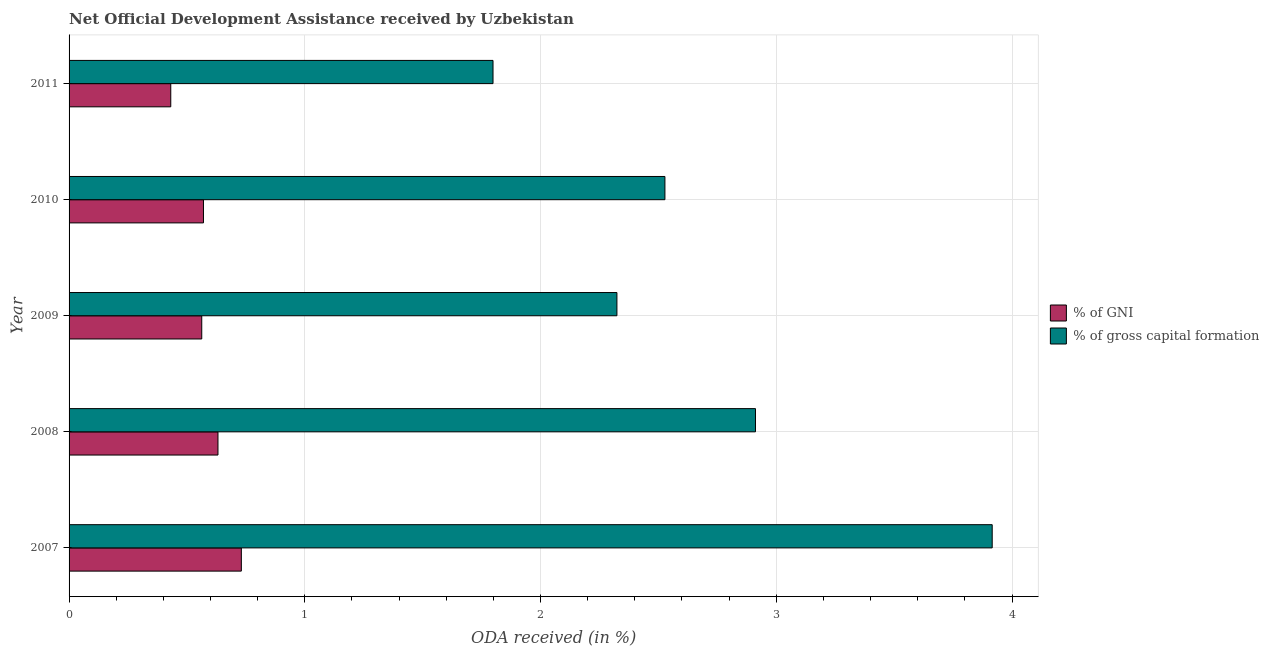Are the number of bars per tick equal to the number of legend labels?
Give a very brief answer. Yes. How many bars are there on the 2nd tick from the top?
Offer a very short reply. 2. How many bars are there on the 1st tick from the bottom?
Make the answer very short. 2. In how many cases, is the number of bars for a given year not equal to the number of legend labels?
Your response must be concise. 0. What is the oda received as percentage of gross capital formation in 2007?
Give a very brief answer. 3.92. Across all years, what is the maximum oda received as percentage of gross capital formation?
Give a very brief answer. 3.92. Across all years, what is the minimum oda received as percentage of gross capital formation?
Your answer should be compact. 1.8. What is the total oda received as percentage of gni in the graph?
Keep it short and to the point. 2.93. What is the difference between the oda received as percentage of gni in 2007 and that in 2010?
Your answer should be very brief. 0.16. What is the difference between the oda received as percentage of gross capital formation in 2010 and the oda received as percentage of gni in 2011?
Ensure brevity in your answer.  2.1. What is the average oda received as percentage of gross capital formation per year?
Your response must be concise. 2.7. In the year 2011, what is the difference between the oda received as percentage of gross capital formation and oda received as percentage of gni?
Make the answer very short. 1.37. What is the ratio of the oda received as percentage of gross capital formation in 2007 to that in 2011?
Provide a succinct answer. 2.18. Is the oda received as percentage of gni in 2009 less than that in 2011?
Give a very brief answer. No. What is the difference between the highest and the second highest oda received as percentage of gni?
Your answer should be very brief. 0.1. What is the difference between the highest and the lowest oda received as percentage of gross capital formation?
Your answer should be compact. 2.12. What does the 1st bar from the top in 2009 represents?
Ensure brevity in your answer.  % of gross capital formation. What does the 1st bar from the bottom in 2009 represents?
Provide a short and direct response. % of GNI. How many bars are there?
Your response must be concise. 10. Are all the bars in the graph horizontal?
Your answer should be very brief. Yes. What is the difference between two consecutive major ticks on the X-axis?
Your response must be concise. 1. Are the values on the major ticks of X-axis written in scientific E-notation?
Make the answer very short. No. Does the graph contain any zero values?
Your answer should be compact. No. How many legend labels are there?
Provide a succinct answer. 2. How are the legend labels stacked?
Make the answer very short. Vertical. What is the title of the graph?
Your answer should be very brief. Net Official Development Assistance received by Uzbekistan. Does "Study and work" appear as one of the legend labels in the graph?
Make the answer very short. No. What is the label or title of the X-axis?
Provide a succinct answer. ODA received (in %). What is the ODA received (in %) in % of GNI in 2007?
Provide a short and direct response. 0.73. What is the ODA received (in %) in % of gross capital formation in 2007?
Provide a succinct answer. 3.92. What is the ODA received (in %) of % of GNI in 2008?
Offer a terse response. 0.63. What is the ODA received (in %) in % of gross capital formation in 2008?
Offer a very short reply. 2.91. What is the ODA received (in %) in % of GNI in 2009?
Give a very brief answer. 0.56. What is the ODA received (in %) in % of gross capital formation in 2009?
Your answer should be very brief. 2.32. What is the ODA received (in %) in % of GNI in 2010?
Offer a very short reply. 0.57. What is the ODA received (in %) in % of gross capital formation in 2010?
Offer a terse response. 2.53. What is the ODA received (in %) in % of GNI in 2011?
Make the answer very short. 0.43. What is the ODA received (in %) in % of gross capital formation in 2011?
Provide a short and direct response. 1.8. Across all years, what is the maximum ODA received (in %) of % of GNI?
Ensure brevity in your answer.  0.73. Across all years, what is the maximum ODA received (in %) of % of gross capital formation?
Your answer should be compact. 3.92. Across all years, what is the minimum ODA received (in %) of % of GNI?
Give a very brief answer. 0.43. Across all years, what is the minimum ODA received (in %) of % of gross capital formation?
Keep it short and to the point. 1.8. What is the total ODA received (in %) of % of GNI in the graph?
Make the answer very short. 2.93. What is the total ODA received (in %) of % of gross capital formation in the graph?
Provide a short and direct response. 13.48. What is the difference between the ODA received (in %) in % of GNI in 2007 and that in 2008?
Offer a terse response. 0.1. What is the difference between the ODA received (in %) of % of gross capital formation in 2007 and that in 2008?
Give a very brief answer. 1. What is the difference between the ODA received (in %) in % of GNI in 2007 and that in 2009?
Provide a short and direct response. 0.17. What is the difference between the ODA received (in %) in % of gross capital formation in 2007 and that in 2009?
Provide a short and direct response. 1.59. What is the difference between the ODA received (in %) of % of GNI in 2007 and that in 2010?
Make the answer very short. 0.16. What is the difference between the ODA received (in %) in % of gross capital formation in 2007 and that in 2010?
Provide a short and direct response. 1.39. What is the difference between the ODA received (in %) in % of GNI in 2007 and that in 2011?
Offer a very short reply. 0.3. What is the difference between the ODA received (in %) in % of gross capital formation in 2007 and that in 2011?
Offer a terse response. 2.12. What is the difference between the ODA received (in %) of % of GNI in 2008 and that in 2009?
Offer a very short reply. 0.07. What is the difference between the ODA received (in %) in % of gross capital formation in 2008 and that in 2009?
Keep it short and to the point. 0.59. What is the difference between the ODA received (in %) of % of GNI in 2008 and that in 2010?
Provide a short and direct response. 0.06. What is the difference between the ODA received (in %) in % of gross capital formation in 2008 and that in 2010?
Offer a terse response. 0.38. What is the difference between the ODA received (in %) of % of GNI in 2008 and that in 2011?
Your response must be concise. 0.2. What is the difference between the ODA received (in %) of % of gross capital formation in 2008 and that in 2011?
Offer a very short reply. 1.11. What is the difference between the ODA received (in %) in % of GNI in 2009 and that in 2010?
Ensure brevity in your answer.  -0.01. What is the difference between the ODA received (in %) in % of gross capital formation in 2009 and that in 2010?
Make the answer very short. -0.2. What is the difference between the ODA received (in %) in % of GNI in 2009 and that in 2011?
Ensure brevity in your answer.  0.13. What is the difference between the ODA received (in %) of % of gross capital formation in 2009 and that in 2011?
Offer a very short reply. 0.53. What is the difference between the ODA received (in %) in % of GNI in 2010 and that in 2011?
Provide a succinct answer. 0.14. What is the difference between the ODA received (in %) of % of gross capital formation in 2010 and that in 2011?
Give a very brief answer. 0.73. What is the difference between the ODA received (in %) in % of GNI in 2007 and the ODA received (in %) in % of gross capital formation in 2008?
Provide a succinct answer. -2.18. What is the difference between the ODA received (in %) of % of GNI in 2007 and the ODA received (in %) of % of gross capital formation in 2009?
Your response must be concise. -1.59. What is the difference between the ODA received (in %) in % of GNI in 2007 and the ODA received (in %) in % of gross capital formation in 2010?
Your answer should be very brief. -1.8. What is the difference between the ODA received (in %) in % of GNI in 2007 and the ODA received (in %) in % of gross capital formation in 2011?
Ensure brevity in your answer.  -1.07. What is the difference between the ODA received (in %) of % of GNI in 2008 and the ODA received (in %) of % of gross capital formation in 2009?
Your answer should be very brief. -1.69. What is the difference between the ODA received (in %) in % of GNI in 2008 and the ODA received (in %) in % of gross capital formation in 2010?
Give a very brief answer. -1.9. What is the difference between the ODA received (in %) in % of GNI in 2008 and the ODA received (in %) in % of gross capital formation in 2011?
Provide a short and direct response. -1.17. What is the difference between the ODA received (in %) of % of GNI in 2009 and the ODA received (in %) of % of gross capital formation in 2010?
Provide a short and direct response. -1.96. What is the difference between the ODA received (in %) of % of GNI in 2009 and the ODA received (in %) of % of gross capital formation in 2011?
Provide a short and direct response. -1.24. What is the difference between the ODA received (in %) in % of GNI in 2010 and the ODA received (in %) in % of gross capital formation in 2011?
Provide a succinct answer. -1.23. What is the average ODA received (in %) of % of GNI per year?
Offer a terse response. 0.59. What is the average ODA received (in %) in % of gross capital formation per year?
Give a very brief answer. 2.7. In the year 2007, what is the difference between the ODA received (in %) in % of GNI and ODA received (in %) in % of gross capital formation?
Offer a terse response. -3.19. In the year 2008, what is the difference between the ODA received (in %) in % of GNI and ODA received (in %) in % of gross capital formation?
Your answer should be compact. -2.28. In the year 2009, what is the difference between the ODA received (in %) in % of GNI and ODA received (in %) in % of gross capital formation?
Keep it short and to the point. -1.76. In the year 2010, what is the difference between the ODA received (in %) in % of GNI and ODA received (in %) in % of gross capital formation?
Keep it short and to the point. -1.96. In the year 2011, what is the difference between the ODA received (in %) in % of GNI and ODA received (in %) in % of gross capital formation?
Provide a succinct answer. -1.37. What is the ratio of the ODA received (in %) in % of GNI in 2007 to that in 2008?
Keep it short and to the point. 1.16. What is the ratio of the ODA received (in %) in % of gross capital formation in 2007 to that in 2008?
Give a very brief answer. 1.34. What is the ratio of the ODA received (in %) of % of GNI in 2007 to that in 2009?
Offer a terse response. 1.3. What is the ratio of the ODA received (in %) of % of gross capital formation in 2007 to that in 2009?
Ensure brevity in your answer.  1.69. What is the ratio of the ODA received (in %) of % of GNI in 2007 to that in 2010?
Make the answer very short. 1.28. What is the ratio of the ODA received (in %) in % of gross capital formation in 2007 to that in 2010?
Provide a short and direct response. 1.55. What is the ratio of the ODA received (in %) of % of GNI in 2007 to that in 2011?
Make the answer very short. 1.69. What is the ratio of the ODA received (in %) in % of gross capital formation in 2007 to that in 2011?
Give a very brief answer. 2.18. What is the ratio of the ODA received (in %) in % of GNI in 2008 to that in 2009?
Provide a short and direct response. 1.12. What is the ratio of the ODA received (in %) of % of gross capital formation in 2008 to that in 2009?
Provide a short and direct response. 1.25. What is the ratio of the ODA received (in %) in % of GNI in 2008 to that in 2010?
Provide a short and direct response. 1.11. What is the ratio of the ODA received (in %) of % of gross capital formation in 2008 to that in 2010?
Your answer should be very brief. 1.15. What is the ratio of the ODA received (in %) of % of GNI in 2008 to that in 2011?
Offer a very short reply. 1.46. What is the ratio of the ODA received (in %) of % of gross capital formation in 2008 to that in 2011?
Offer a very short reply. 1.62. What is the ratio of the ODA received (in %) in % of GNI in 2009 to that in 2010?
Your answer should be very brief. 0.99. What is the ratio of the ODA received (in %) of % of gross capital formation in 2009 to that in 2010?
Provide a succinct answer. 0.92. What is the ratio of the ODA received (in %) of % of GNI in 2009 to that in 2011?
Your answer should be compact. 1.3. What is the ratio of the ODA received (in %) of % of gross capital formation in 2009 to that in 2011?
Ensure brevity in your answer.  1.29. What is the ratio of the ODA received (in %) in % of GNI in 2010 to that in 2011?
Your answer should be compact. 1.32. What is the ratio of the ODA received (in %) of % of gross capital formation in 2010 to that in 2011?
Keep it short and to the point. 1.41. What is the difference between the highest and the second highest ODA received (in %) in % of GNI?
Provide a short and direct response. 0.1. What is the difference between the highest and the lowest ODA received (in %) in % of GNI?
Provide a succinct answer. 0.3. What is the difference between the highest and the lowest ODA received (in %) of % of gross capital formation?
Give a very brief answer. 2.12. 